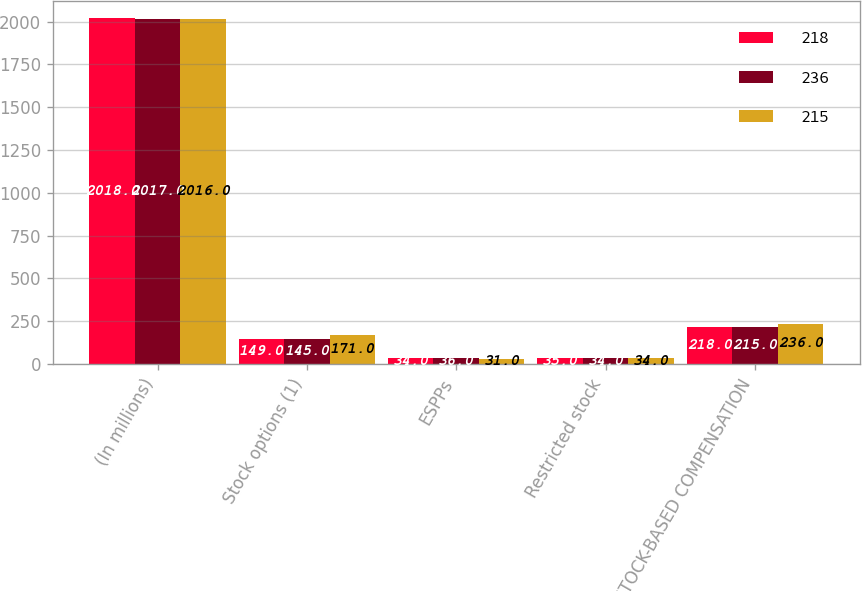Convert chart. <chart><loc_0><loc_0><loc_500><loc_500><stacked_bar_chart><ecel><fcel>(In millions)<fcel>Stock options (1)<fcel>ESPPs<fcel>Restricted stock<fcel>TOTAL STOCK-BASED COMPENSATION<nl><fcel>218<fcel>2018<fcel>149<fcel>34<fcel>35<fcel>218<nl><fcel>236<fcel>2017<fcel>145<fcel>36<fcel>34<fcel>215<nl><fcel>215<fcel>2016<fcel>171<fcel>31<fcel>34<fcel>236<nl></chart> 